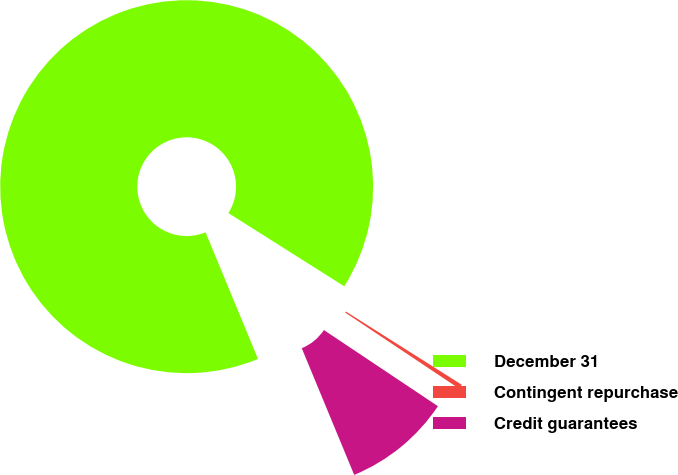<chart> <loc_0><loc_0><loc_500><loc_500><pie_chart><fcel>December 31<fcel>Contingent repurchase<fcel>Credit guarantees<nl><fcel>90.21%<fcel>0.4%<fcel>9.38%<nl></chart> 